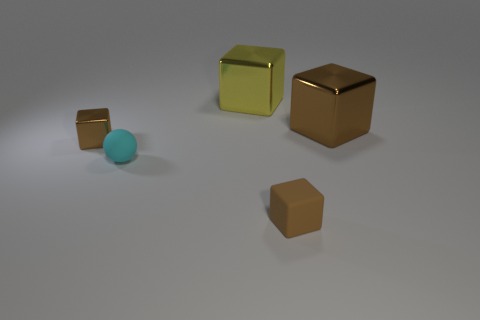How many brown blocks must be subtracted to get 1 brown blocks? 2 Add 1 small cubes. How many objects exist? 6 Subtract all yellow blocks. How many blocks are left? 3 Subtract all yellow cubes. How many cubes are left? 3 Subtract 0 brown balls. How many objects are left? 5 Subtract all blocks. How many objects are left? 1 Subtract 1 blocks. How many blocks are left? 3 Subtract all purple blocks. Subtract all gray spheres. How many blocks are left? 4 Subtract all cyan cylinders. How many red blocks are left? 0 Subtract all tiny brown blocks. Subtract all cyan shiny objects. How many objects are left? 3 